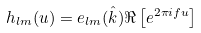<formula> <loc_0><loc_0><loc_500><loc_500>h _ { l m } ( u ) = e _ { l m } ( \hat { k } ) \Re \left [ e ^ { 2 \pi i f u } \right ]</formula> 